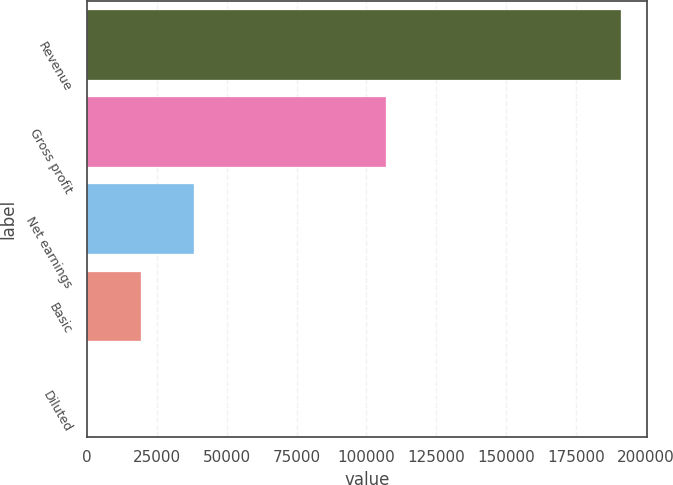Convert chart. <chart><loc_0><loc_0><loc_500><loc_500><bar_chart><fcel>Revenue<fcel>Gross profit<fcel>Net earnings<fcel>Basic<fcel>Diluted<nl><fcel>191104<fcel>107023<fcel>38221<fcel>19110.6<fcel>0.22<nl></chart> 